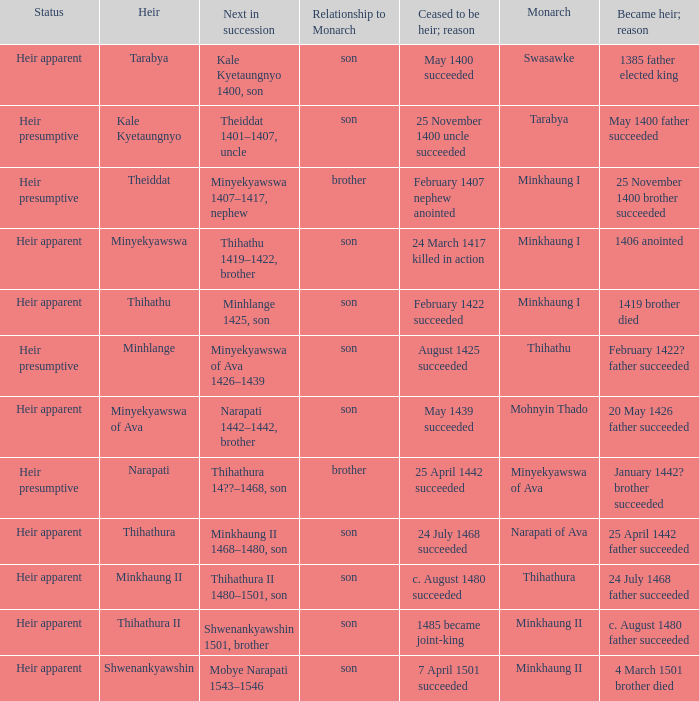Could you help me parse every detail presented in this table? {'header': ['Status', 'Heir', 'Next in succession', 'Relationship to Monarch', 'Ceased to be heir; reason', 'Monarch', 'Became heir; reason'], 'rows': [['Heir apparent', 'Tarabya', 'Kale Kyetaungnyo 1400, son', 'son', 'May 1400 succeeded', 'Swasawke', '1385 father elected king'], ['Heir presumptive', 'Kale Kyetaungnyo', 'Theiddat 1401–1407, uncle', 'son', '25 November 1400 uncle succeeded', 'Tarabya', 'May 1400 father succeeded'], ['Heir presumptive', 'Theiddat', 'Minyekyawswa 1407–1417, nephew', 'brother', 'February 1407 nephew anointed', 'Minkhaung I', '25 November 1400 brother succeeded'], ['Heir apparent', 'Minyekyawswa', 'Thihathu 1419–1422, brother', 'son', '24 March 1417 killed in action', 'Minkhaung I', '1406 anointed'], ['Heir apparent', 'Thihathu', 'Minhlange 1425, son', 'son', 'February 1422 succeeded', 'Minkhaung I', '1419 brother died'], ['Heir presumptive', 'Minhlange', 'Minyekyawswa of Ava 1426–1439', 'son', 'August 1425 succeeded', 'Thihathu', 'February 1422? father succeeded'], ['Heir apparent', 'Minyekyawswa of Ava', 'Narapati 1442–1442, brother', 'son', 'May 1439 succeeded', 'Mohnyin Thado', '20 May 1426 father succeeded'], ['Heir presumptive', 'Narapati', 'Thihathura 14??–1468, son', 'brother', '25 April 1442 succeeded', 'Minyekyawswa of Ava', 'January 1442? brother succeeded'], ['Heir apparent', 'Thihathura', 'Minkhaung II 1468–1480, son', 'son', '24 July 1468 succeeded', 'Narapati of Ava', '25 April 1442 father succeeded'], ['Heir apparent', 'Minkhaung II', 'Thihathura II 1480–1501, son', 'son', 'c. August 1480 succeeded', 'Thihathura', '24 July 1468 father succeeded'], ['Heir apparent', 'Thihathura II', 'Shwenankyawshin 1501, brother', 'son', '1485 became joint-king', 'Minkhaung II', 'c. August 1480 father succeeded'], ['Heir apparent', 'Shwenankyawshin', 'Mobye Narapati 1543–1546', 'son', '7 April 1501 succeeded', 'Minkhaung II', '4 March 1501 brother died']]} What was the relationship to monarch of the heir Minyekyawswa? Son. 